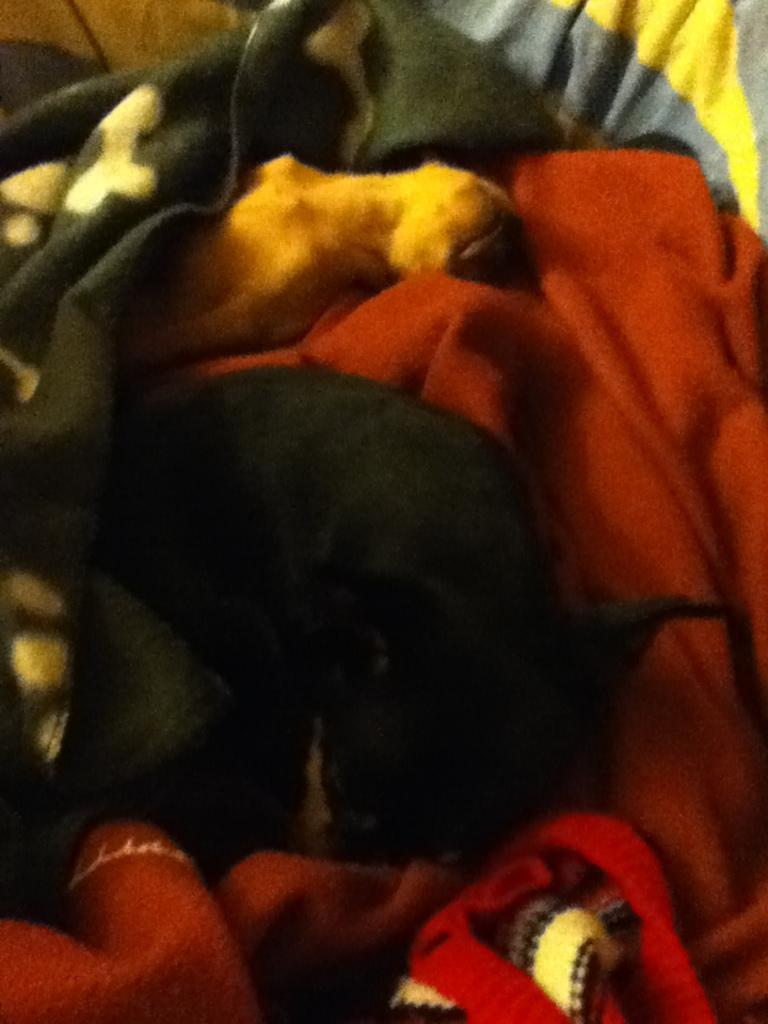Describe this image in one or two sentences. In this image, I can see two animals on the blankets. 